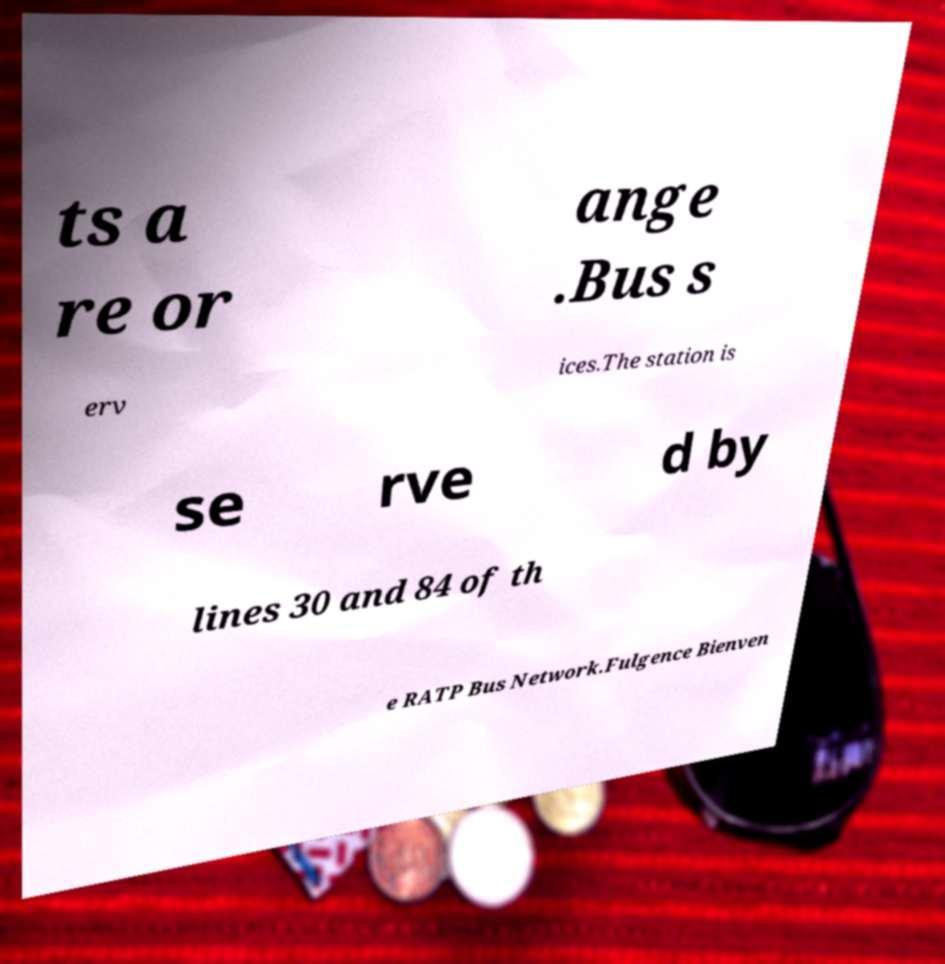Could you extract and type out the text from this image? ts a re or ange .Bus s erv ices.The station is se rve d by lines 30 and 84 of th e RATP Bus Network.Fulgence Bienven 